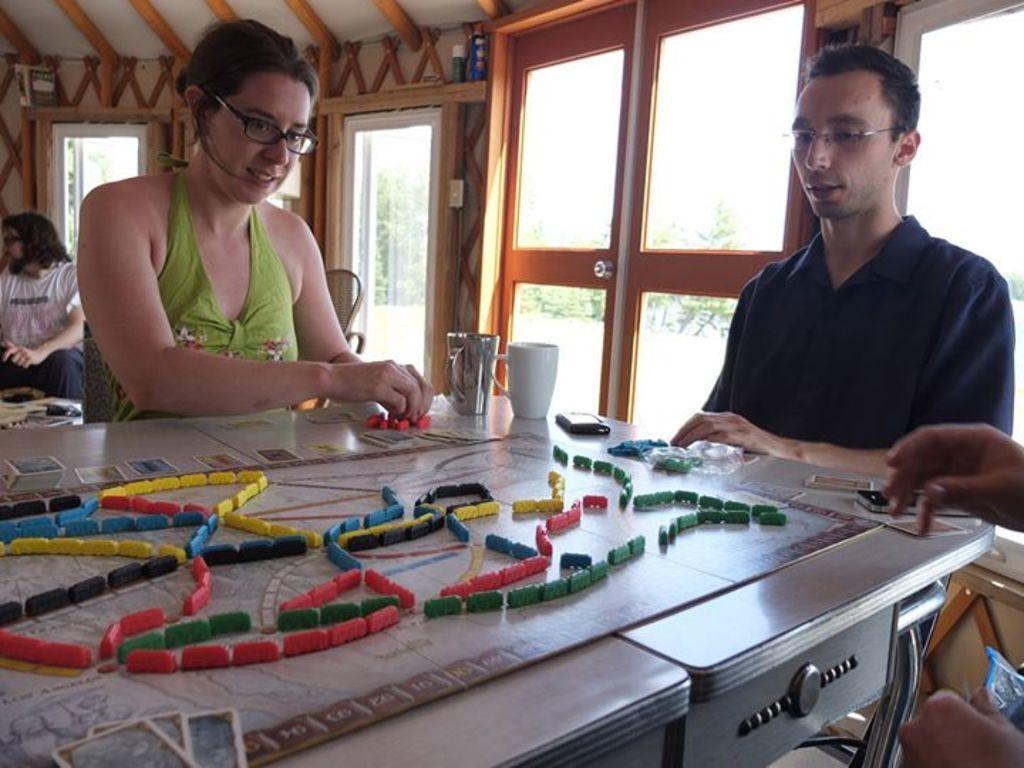In one or two sentences, can you explain what this image depicts? The four persons are sitting on a chairs. They are wearing spectacles. There is a table. There is a logo's,mobile on a table. We can see in the background door ,wooden wall and trees. 